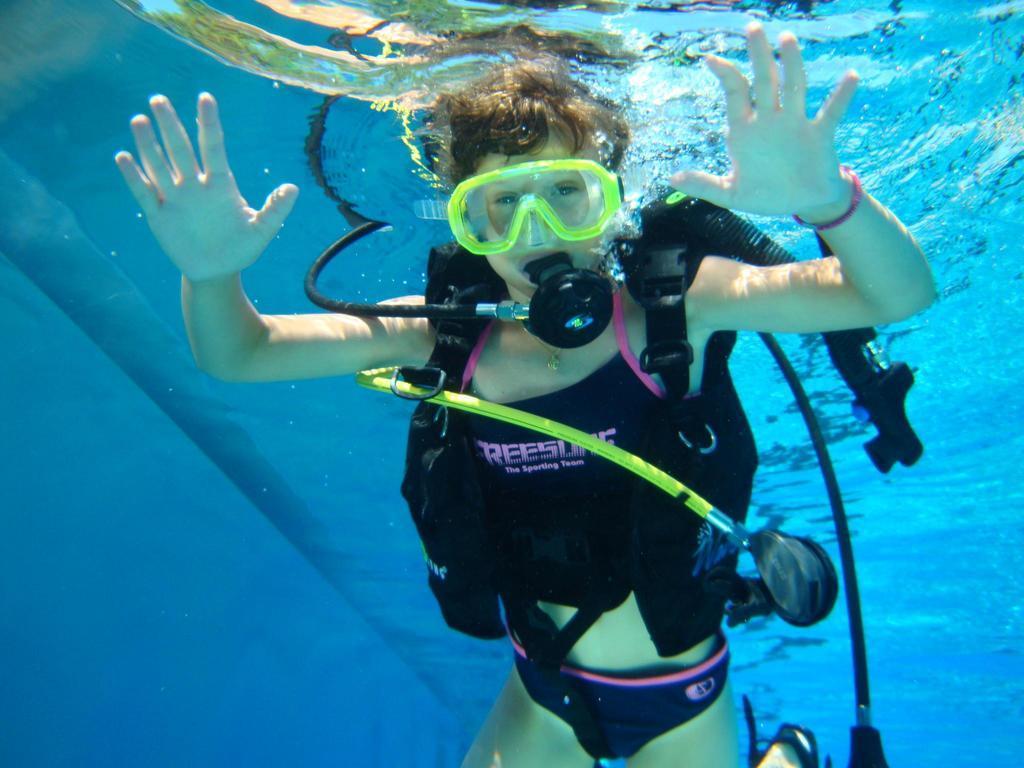Please provide a concise description of this image. In this picture I can see a person wearing gas mask, swimming goggles, swimming costume and swimming in the water. 